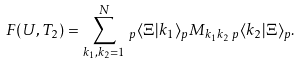Convert formula to latex. <formula><loc_0><loc_0><loc_500><loc_500>F ( U , T _ { 2 } ) = \sum _ { k _ { 1 } , k _ { 2 } = 1 } ^ { N } \, _ { p } \langle \Xi | k _ { 1 } \rangle _ { p } M _ { k _ { 1 } k _ { 2 } } \, _ { p } \langle k _ { 2 } | \Xi \rangle _ { p } .</formula> 